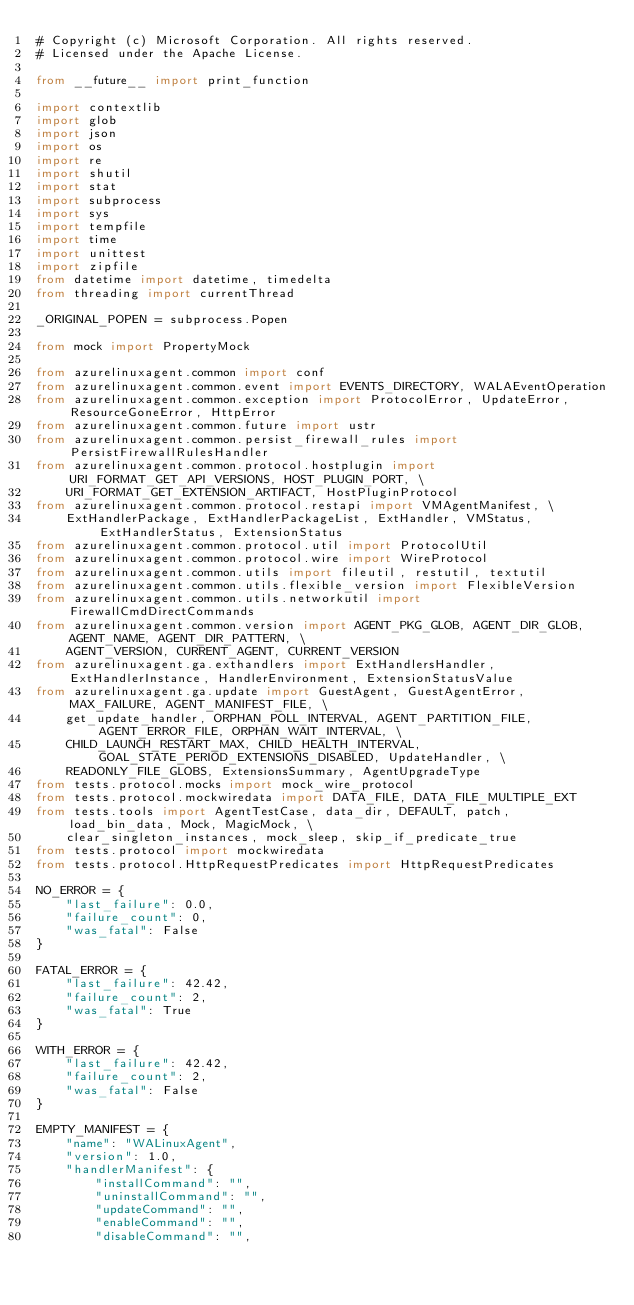<code> <loc_0><loc_0><loc_500><loc_500><_Python_># Copyright (c) Microsoft Corporation. All rights reserved.
# Licensed under the Apache License.

from __future__ import print_function

import contextlib
import glob
import json
import os
import re
import shutil
import stat
import subprocess
import sys
import tempfile
import time
import unittest
import zipfile
from datetime import datetime, timedelta
from threading import currentThread

_ORIGINAL_POPEN = subprocess.Popen

from mock import PropertyMock

from azurelinuxagent.common import conf
from azurelinuxagent.common.event import EVENTS_DIRECTORY, WALAEventOperation
from azurelinuxagent.common.exception import ProtocolError, UpdateError, ResourceGoneError, HttpError
from azurelinuxagent.common.future import ustr
from azurelinuxagent.common.persist_firewall_rules import PersistFirewallRulesHandler
from azurelinuxagent.common.protocol.hostplugin import URI_FORMAT_GET_API_VERSIONS, HOST_PLUGIN_PORT, \
    URI_FORMAT_GET_EXTENSION_ARTIFACT, HostPluginProtocol
from azurelinuxagent.common.protocol.restapi import VMAgentManifest, \
    ExtHandlerPackage, ExtHandlerPackageList, ExtHandler, VMStatus, ExtHandlerStatus, ExtensionStatus
from azurelinuxagent.common.protocol.util import ProtocolUtil
from azurelinuxagent.common.protocol.wire import WireProtocol
from azurelinuxagent.common.utils import fileutil, restutil, textutil
from azurelinuxagent.common.utils.flexible_version import FlexibleVersion
from azurelinuxagent.common.utils.networkutil import FirewallCmdDirectCommands
from azurelinuxagent.common.version import AGENT_PKG_GLOB, AGENT_DIR_GLOB, AGENT_NAME, AGENT_DIR_PATTERN, \
    AGENT_VERSION, CURRENT_AGENT, CURRENT_VERSION
from azurelinuxagent.ga.exthandlers import ExtHandlersHandler, ExtHandlerInstance, HandlerEnvironment, ExtensionStatusValue
from azurelinuxagent.ga.update import GuestAgent, GuestAgentError, MAX_FAILURE, AGENT_MANIFEST_FILE, \
    get_update_handler, ORPHAN_POLL_INTERVAL, AGENT_PARTITION_FILE, AGENT_ERROR_FILE, ORPHAN_WAIT_INTERVAL, \
    CHILD_LAUNCH_RESTART_MAX, CHILD_HEALTH_INTERVAL, GOAL_STATE_PERIOD_EXTENSIONS_DISABLED, UpdateHandler, \
    READONLY_FILE_GLOBS, ExtensionsSummary, AgentUpgradeType
from tests.protocol.mocks import mock_wire_protocol
from tests.protocol.mockwiredata import DATA_FILE, DATA_FILE_MULTIPLE_EXT
from tests.tools import AgentTestCase, data_dir, DEFAULT, patch, load_bin_data, Mock, MagicMock, \
    clear_singleton_instances, mock_sleep, skip_if_predicate_true
from tests.protocol import mockwiredata
from tests.protocol.HttpRequestPredicates import HttpRequestPredicates

NO_ERROR = {
    "last_failure": 0.0,
    "failure_count": 0,
    "was_fatal": False
}

FATAL_ERROR = {
    "last_failure": 42.42,
    "failure_count": 2,
    "was_fatal": True
}

WITH_ERROR = {
    "last_failure": 42.42,
    "failure_count": 2,
    "was_fatal": False
}

EMPTY_MANIFEST = {
    "name": "WALinuxAgent",
    "version": 1.0,
    "handlerManifest": {
        "installCommand": "",
        "uninstallCommand": "",
        "updateCommand": "",
        "enableCommand": "",
        "disableCommand": "",</code> 